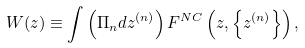Convert formula to latex. <formula><loc_0><loc_0><loc_500><loc_500>W ( z ) \equiv \int \left ( \Pi _ { n } d z ^ { ( n ) } \right ) F ^ { N C } \left ( z , \left \{ z ^ { ( n ) } \right \} \right ) ,</formula> 